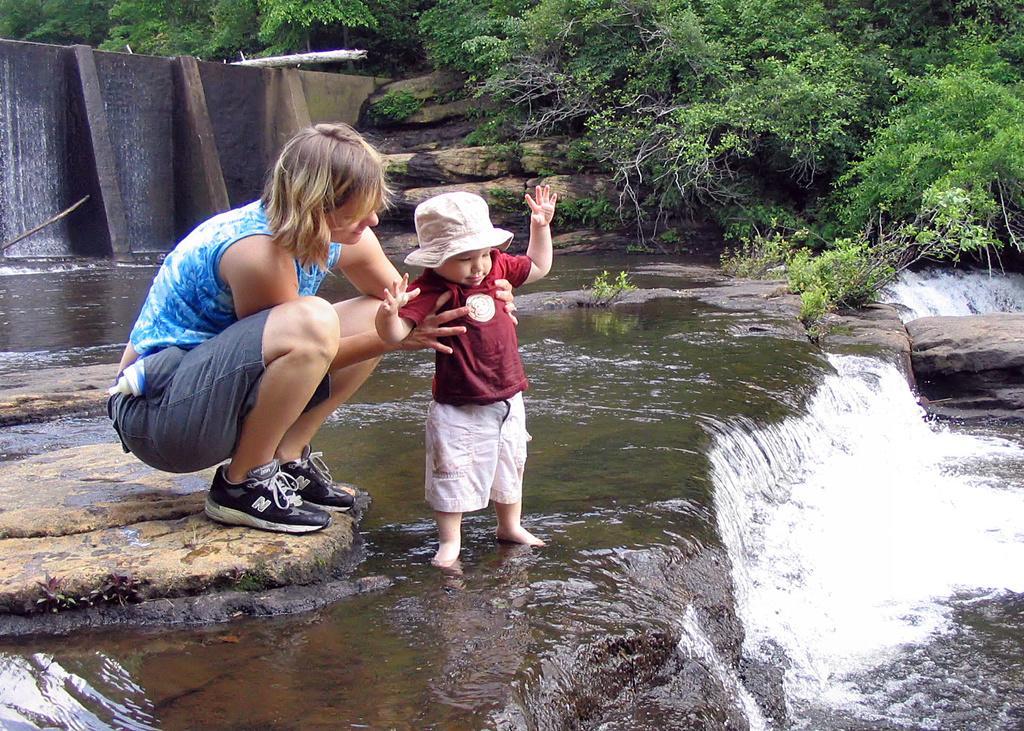Please provide a concise description of this image. In this image I can see a woman wearing blue and grey colored dress is sitting on a rock and holding a baby who is wearing maroon and white colored dress. I can see water, few rocks and few trees. 